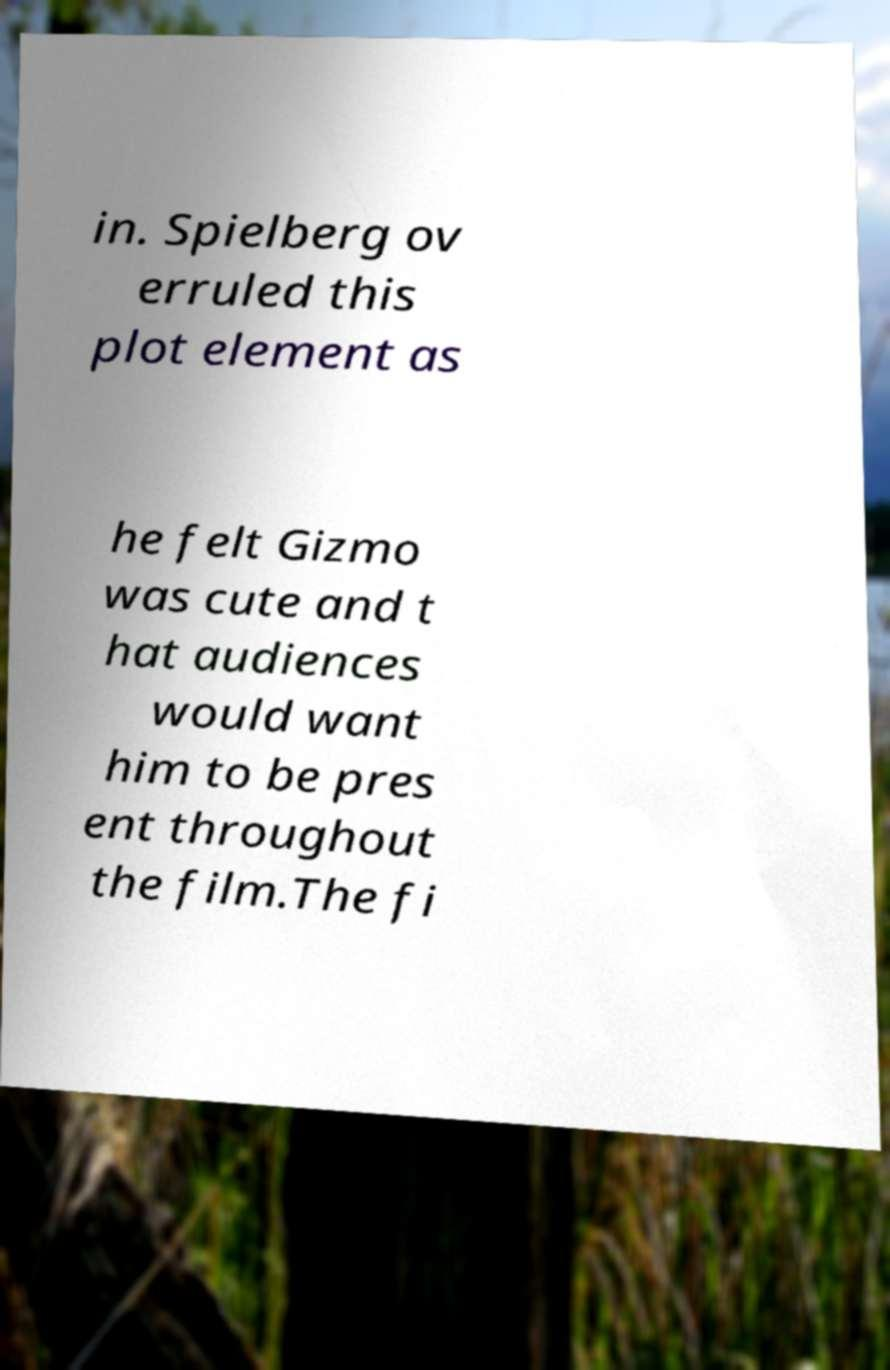I need the written content from this picture converted into text. Can you do that? in. Spielberg ov erruled this plot element as he felt Gizmo was cute and t hat audiences would want him to be pres ent throughout the film.The fi 